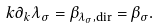Convert formula to latex. <formula><loc_0><loc_0><loc_500><loc_500>k \partial _ { k } \lambda _ { \sigma } = \beta _ { \lambda _ { \sigma } , \text {dir} } = \beta _ { \sigma } .</formula> 